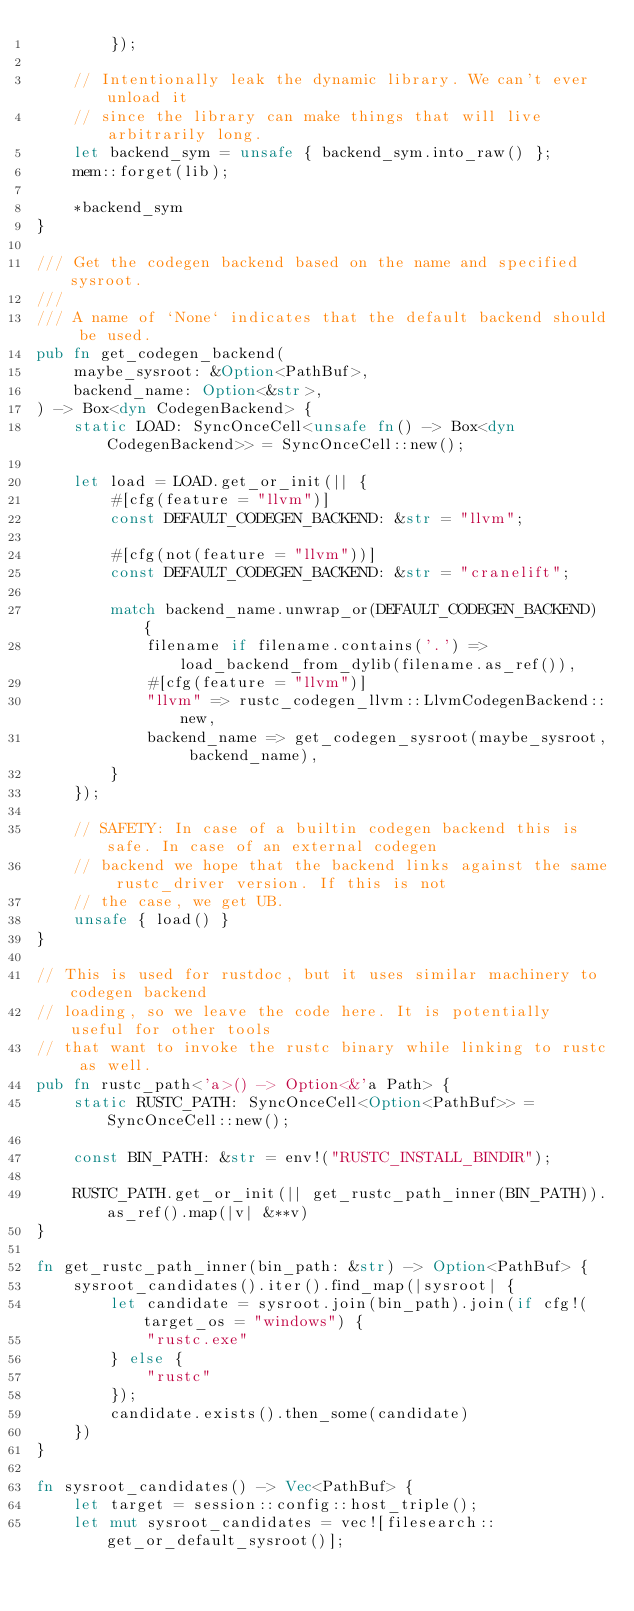<code> <loc_0><loc_0><loc_500><loc_500><_Rust_>        });

    // Intentionally leak the dynamic library. We can't ever unload it
    // since the library can make things that will live arbitrarily long.
    let backend_sym = unsafe { backend_sym.into_raw() };
    mem::forget(lib);

    *backend_sym
}

/// Get the codegen backend based on the name and specified sysroot.
///
/// A name of `None` indicates that the default backend should be used.
pub fn get_codegen_backend(
    maybe_sysroot: &Option<PathBuf>,
    backend_name: Option<&str>,
) -> Box<dyn CodegenBackend> {
    static LOAD: SyncOnceCell<unsafe fn() -> Box<dyn CodegenBackend>> = SyncOnceCell::new();

    let load = LOAD.get_or_init(|| {
        #[cfg(feature = "llvm")]
        const DEFAULT_CODEGEN_BACKEND: &str = "llvm";

        #[cfg(not(feature = "llvm"))]
        const DEFAULT_CODEGEN_BACKEND: &str = "cranelift";

        match backend_name.unwrap_or(DEFAULT_CODEGEN_BACKEND) {
            filename if filename.contains('.') => load_backend_from_dylib(filename.as_ref()),
            #[cfg(feature = "llvm")]
            "llvm" => rustc_codegen_llvm::LlvmCodegenBackend::new,
            backend_name => get_codegen_sysroot(maybe_sysroot, backend_name),
        }
    });

    // SAFETY: In case of a builtin codegen backend this is safe. In case of an external codegen
    // backend we hope that the backend links against the same rustc_driver version. If this is not
    // the case, we get UB.
    unsafe { load() }
}

// This is used for rustdoc, but it uses similar machinery to codegen backend
// loading, so we leave the code here. It is potentially useful for other tools
// that want to invoke the rustc binary while linking to rustc as well.
pub fn rustc_path<'a>() -> Option<&'a Path> {
    static RUSTC_PATH: SyncOnceCell<Option<PathBuf>> = SyncOnceCell::new();

    const BIN_PATH: &str = env!("RUSTC_INSTALL_BINDIR");

    RUSTC_PATH.get_or_init(|| get_rustc_path_inner(BIN_PATH)).as_ref().map(|v| &**v)
}

fn get_rustc_path_inner(bin_path: &str) -> Option<PathBuf> {
    sysroot_candidates().iter().find_map(|sysroot| {
        let candidate = sysroot.join(bin_path).join(if cfg!(target_os = "windows") {
            "rustc.exe"
        } else {
            "rustc"
        });
        candidate.exists().then_some(candidate)
    })
}

fn sysroot_candidates() -> Vec<PathBuf> {
    let target = session::config::host_triple();
    let mut sysroot_candidates = vec![filesearch::get_or_default_sysroot()];</code> 